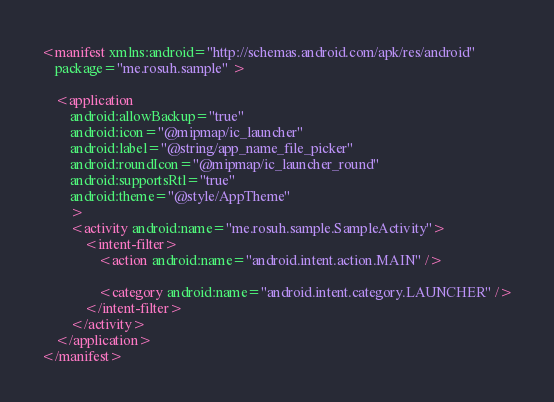Convert code to text. <code><loc_0><loc_0><loc_500><loc_500><_XML_><manifest xmlns:android="http://schemas.android.com/apk/res/android"
    package="me.rosuh.sample" >

    <application
        android:allowBackup="true"
        android:icon="@mipmap/ic_launcher"
        android:label="@string/app_name_file_picker"
        android:roundIcon="@mipmap/ic_launcher_round"
        android:supportsRtl="true"
        android:theme="@style/AppTheme"
        >
        <activity android:name="me.rosuh.sample.SampleActivity">
            <intent-filter>
                <action android:name="android.intent.action.MAIN" />

                <category android:name="android.intent.category.LAUNCHER" />
            </intent-filter>
        </activity>
    </application>
</manifest>
</code> 